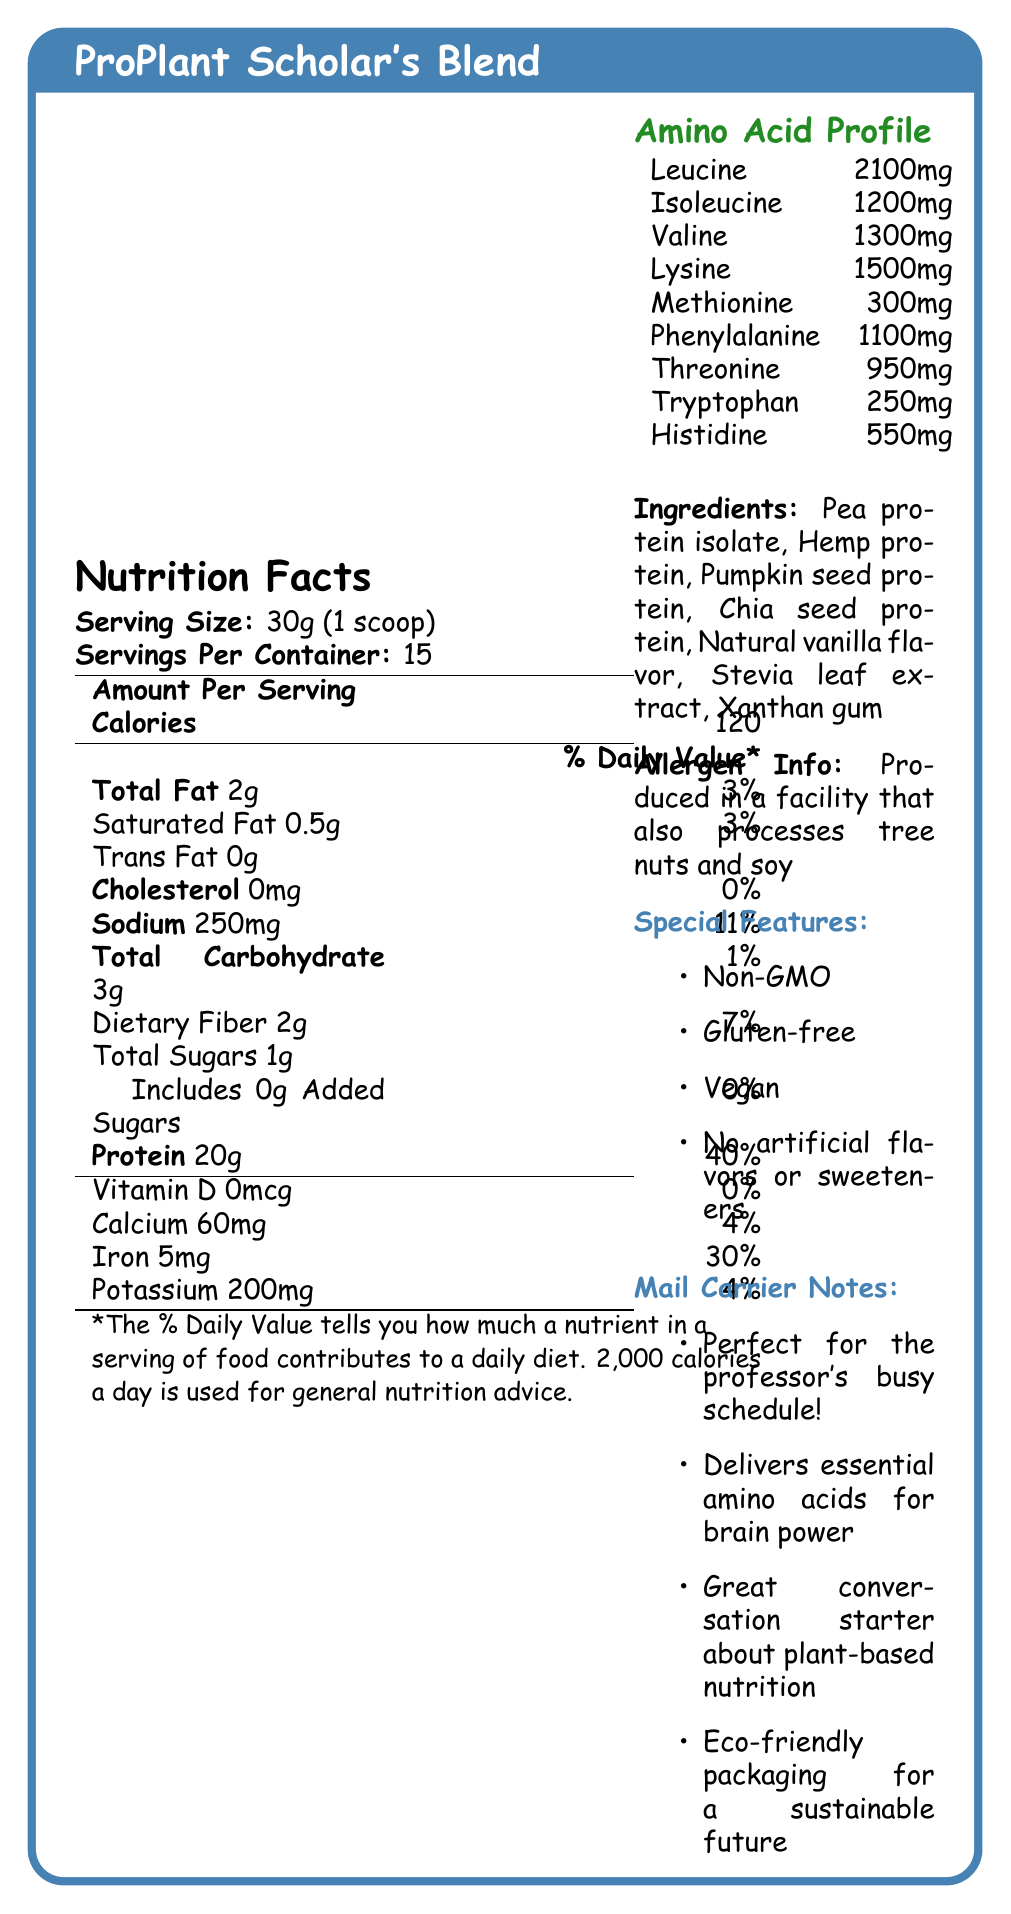what is the serving size? The document specifies the serving size as "30g (1 scoop)" in the Nutrition Facts section.
Answer: 30g (1 scoop) how many servings are there per container? The document lists "Servings Per Container: 15" under the Nutrition Facts section.
Answer: 15 what is the total fat amount per serving? The Total Fat amount per serving is shown as "2g" in the nutrition facts table.
Answer: 2g what is the daily value percentage for protein? The daily value percentage for protein is shown as "40%" in the Nutrition Facts table.
Answer: 40% which ingredient is listed first? Under the Ingredients section, "Pea protein isolate" is listed first.
Answer: Pea protein isolate what is the allergen information provided? The allergen information is given as "Produced in a facility that also processes tree nuts and soy".
Answer: Produced in a facility that also processes tree nuts and soy how much leucine is in the protein powder? The amount of leucine is listed as "2100mg" under the Amino Acid Profile.
Answer: 2100mg how many grams of saturated fat are in a serving? The document specifies "Saturated Fat 0.5g" in the Nutrition Facts section.
Answer: 0.5g what are the special features of this product? A. Contains GMOs B. Vegan C. Contains artificial flavors D. Gluten-free The document lists special features as "Non-GMO, Gluten-free, Vegan, No artificial flavors or sweeteners".
Answer: B, D how many milligrams of sodium does one serving contain? A. 200mg B. 250mg C. 300mg D. 350mg The document states that one serving contains "Sodium 250mg".
Answer: B does this product contain any cholesterol? The document indicates "Cholesterol 0mg" in the Nutrition Facts section.
Answer: No is this product suitable for vegans? The document lists "Vegan" under the Special Features section.
Answer: Yes describe the entire document The document combines a nutrition facts label, ingredient list, allergen information, special features, and a personalized note from the mail carrier to provide comprehensive information about the "ProPlant Scholar's Blend" product.
Answer: The document provides detailed nutritional information about the "ProPlant Scholar's Blend" plant-based protein powder, including its serving size, calories, macronutrient breakdown, amino acid profile, ingredients, allergen information, and special features like being Non-GMO, gluten-free, and vegan. Additionally, it includes a special note from the mail carrier highlighting the product's suitability for a busy schedule, brain power benefits, eco-friendliness, and interest in plant-based nutrition. how does this protein powder support brain power? The mail carrier notes state that the protein powder "Delivers essential amino acids for brain power".
Answer: Delivers essential amino acids what is the total sugar content per serving? The document lists "Total Sugars 1g" in the Nutrition Facts section.
Answer: 1g does this product have any artificial flavors or sweeteners? The document states under Special Features, "No artificial flavors or sweeteners".
Answer: No what certification or special features make this protein powder environmentally friendly? Under Mail Carrier Notes, the document mentions "Eco-friendly packaging for a sustainable future".
Answer: Eco-friendly packaging what is the unsaturated fat content? The document does not provide information on the unsaturated fat content explicitly.
Answer: Cannot be determined 